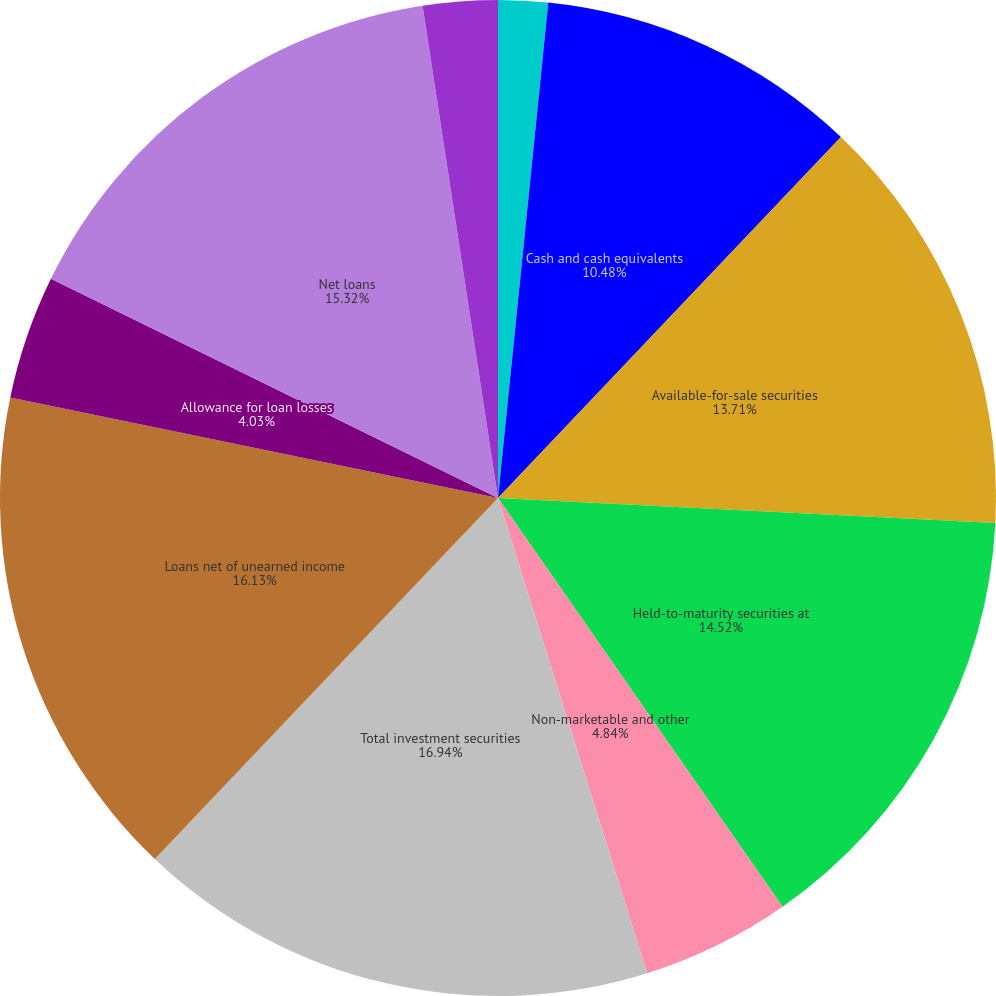Convert chart to OTSL. <chart><loc_0><loc_0><loc_500><loc_500><pie_chart><fcel>(Dollars in thousands except<fcel>Cash and cash equivalents<fcel>Available-for-sale securities<fcel>Held-to-maturity securities at<fcel>Non-marketable and other<fcel>Total investment securities<fcel>Loans net of unearned income<fcel>Allowance for loan losses<fcel>Net loans<fcel>Premises and equipment net of<nl><fcel>1.61%<fcel>10.48%<fcel>13.71%<fcel>14.52%<fcel>4.84%<fcel>16.94%<fcel>16.13%<fcel>4.03%<fcel>15.32%<fcel>2.42%<nl></chart> 